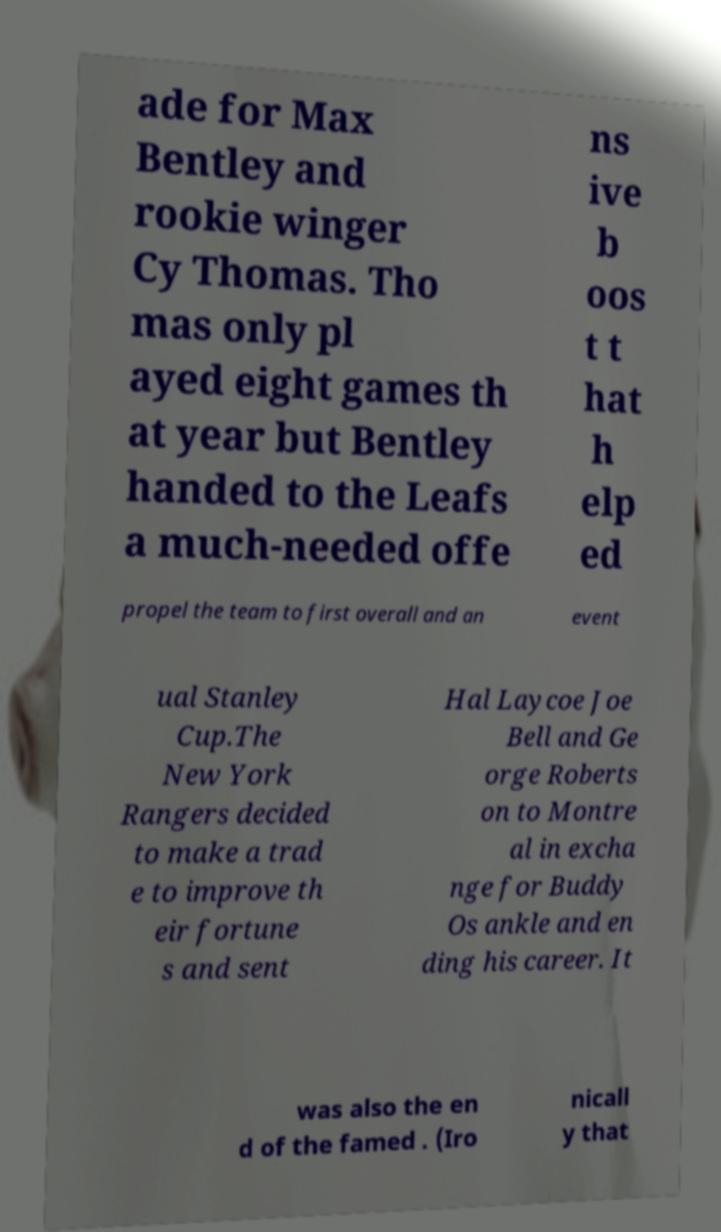What messages or text are displayed in this image? I need them in a readable, typed format. ade for Max Bentley and rookie winger Cy Thomas. Tho mas only pl ayed eight games th at year but Bentley handed to the Leafs a much-needed offe ns ive b oos t t hat h elp ed propel the team to first overall and an event ual Stanley Cup.The New York Rangers decided to make a trad e to improve th eir fortune s and sent Hal Laycoe Joe Bell and Ge orge Roberts on to Montre al in excha nge for Buddy Os ankle and en ding his career. It was also the en d of the famed . (Iro nicall y that 